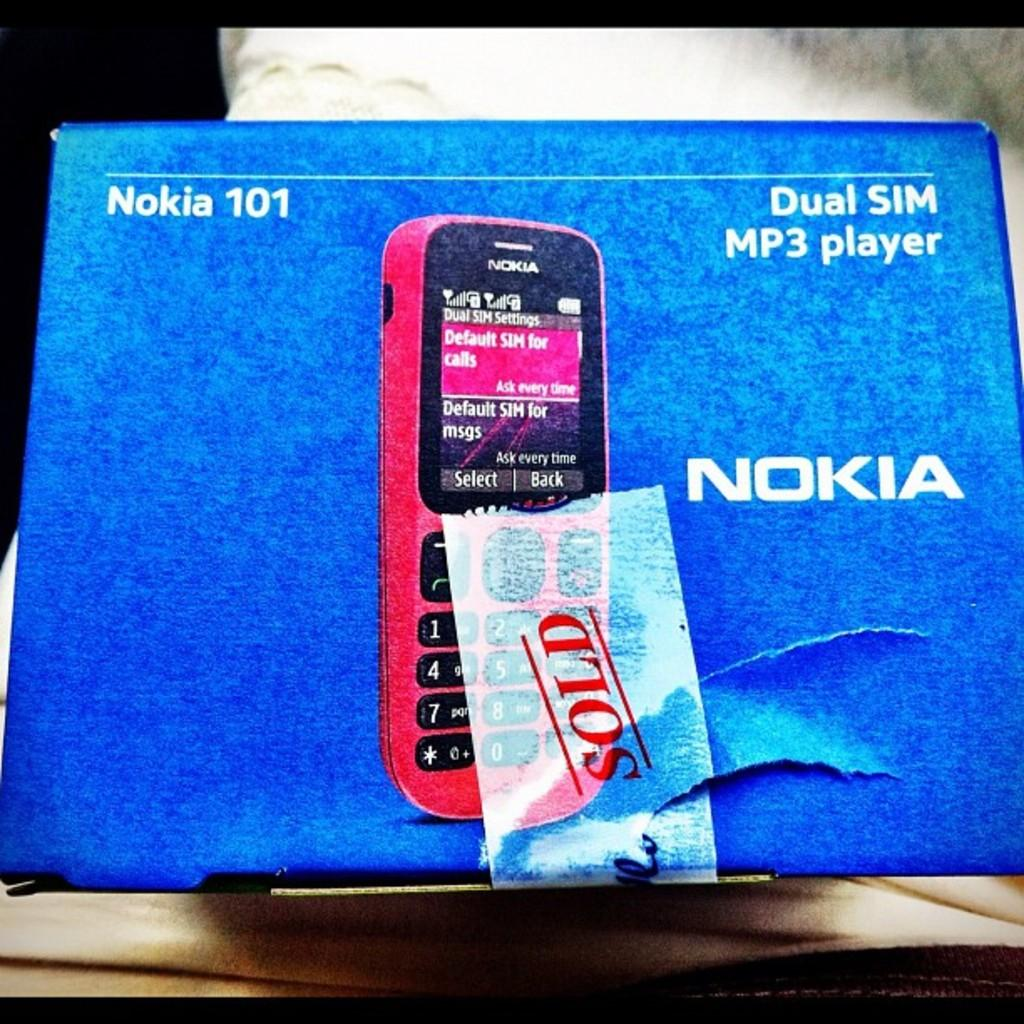<image>
Provide a brief description of the given image. A sign for a Nokia phone shows the word Sold. 